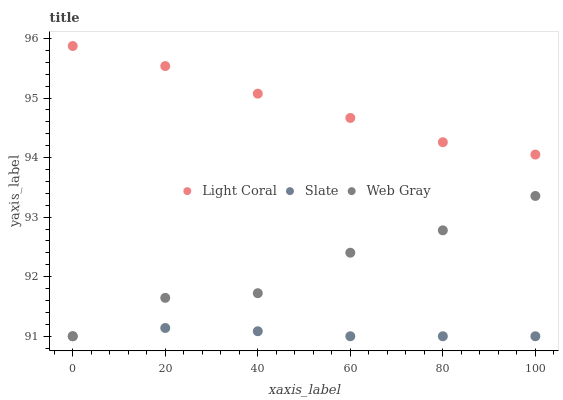Does Slate have the minimum area under the curve?
Answer yes or no. Yes. Does Light Coral have the maximum area under the curve?
Answer yes or no. Yes. Does Web Gray have the minimum area under the curve?
Answer yes or no. No. Does Web Gray have the maximum area under the curve?
Answer yes or no. No. Is Slate the smoothest?
Answer yes or no. Yes. Is Web Gray the roughest?
Answer yes or no. Yes. Is Web Gray the smoothest?
Answer yes or no. No. Is Slate the roughest?
Answer yes or no. No. Does Slate have the lowest value?
Answer yes or no. Yes. Does Light Coral have the highest value?
Answer yes or no. Yes. Does Web Gray have the highest value?
Answer yes or no. No. Is Web Gray less than Light Coral?
Answer yes or no. Yes. Is Light Coral greater than Web Gray?
Answer yes or no. Yes. Does Slate intersect Web Gray?
Answer yes or no. Yes. Is Slate less than Web Gray?
Answer yes or no. No. Is Slate greater than Web Gray?
Answer yes or no. No. Does Web Gray intersect Light Coral?
Answer yes or no. No. 